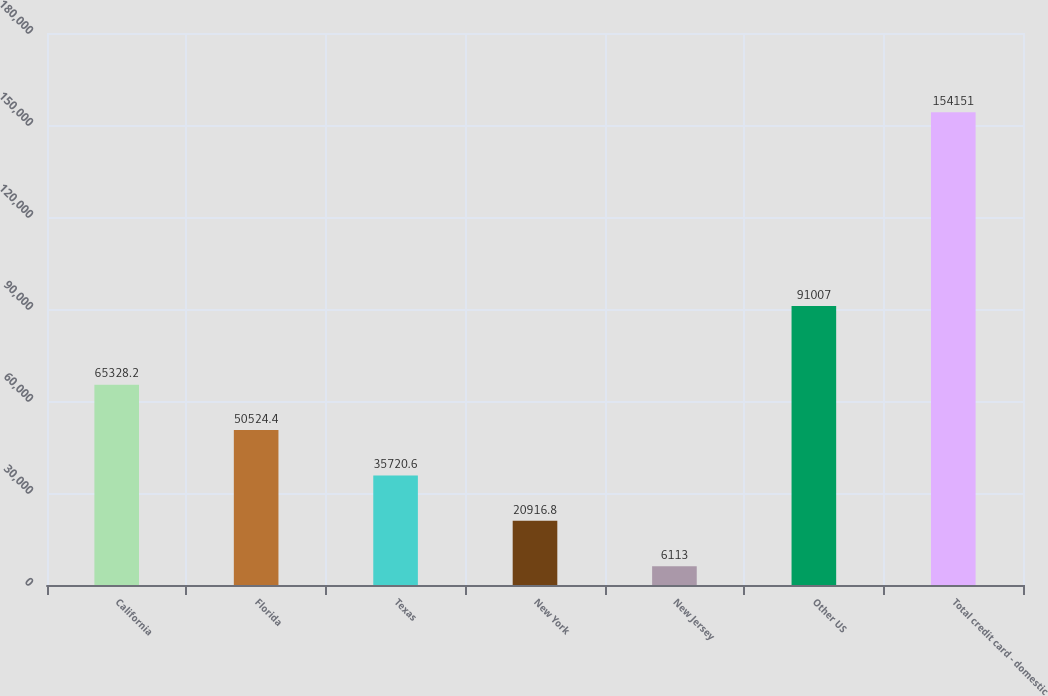<chart> <loc_0><loc_0><loc_500><loc_500><bar_chart><fcel>California<fcel>Florida<fcel>Texas<fcel>New York<fcel>New Jersey<fcel>Other US<fcel>Total credit card - domestic<nl><fcel>65328.2<fcel>50524.4<fcel>35720.6<fcel>20916.8<fcel>6113<fcel>91007<fcel>154151<nl></chart> 